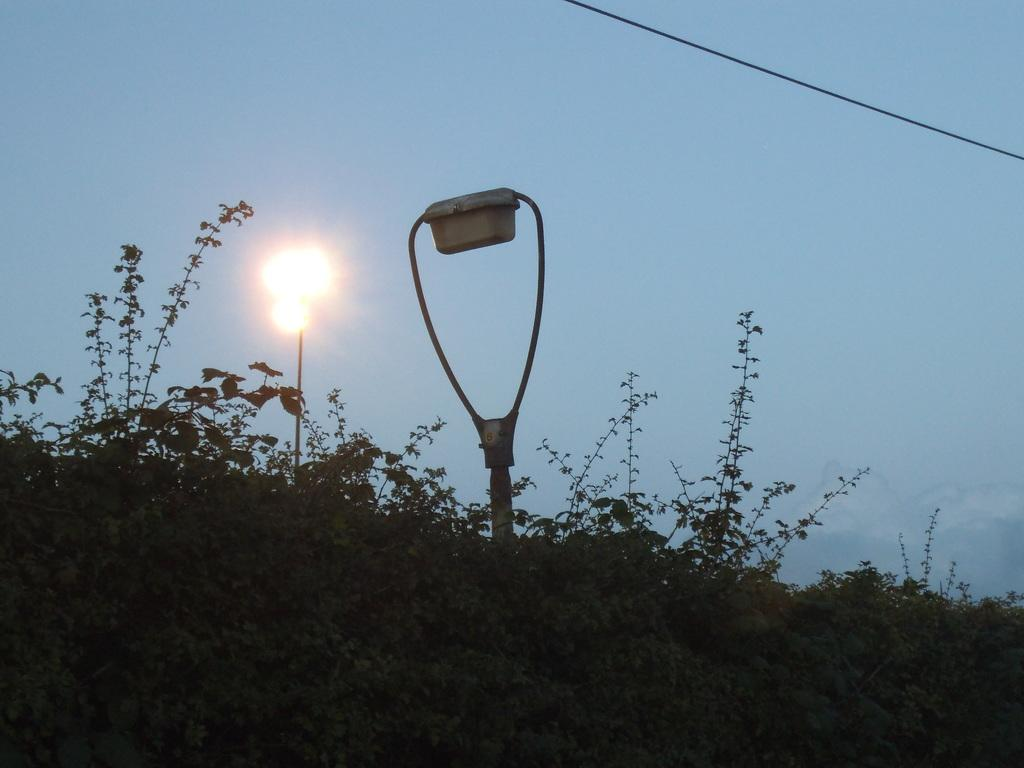What type of vegetation is present in the image? There are plants and trees in the front bottom side of the image. What type of man-made object can be seen in the image? There is a street lamp in the image. What color is the sky in the image? The sky is blue in the image. Can you hear the music being played by the flock of birds in the image? There are no birds or music present in the image. How does the street lamp move around in the image? The street lamp does not move around in the image; it is stationary. 